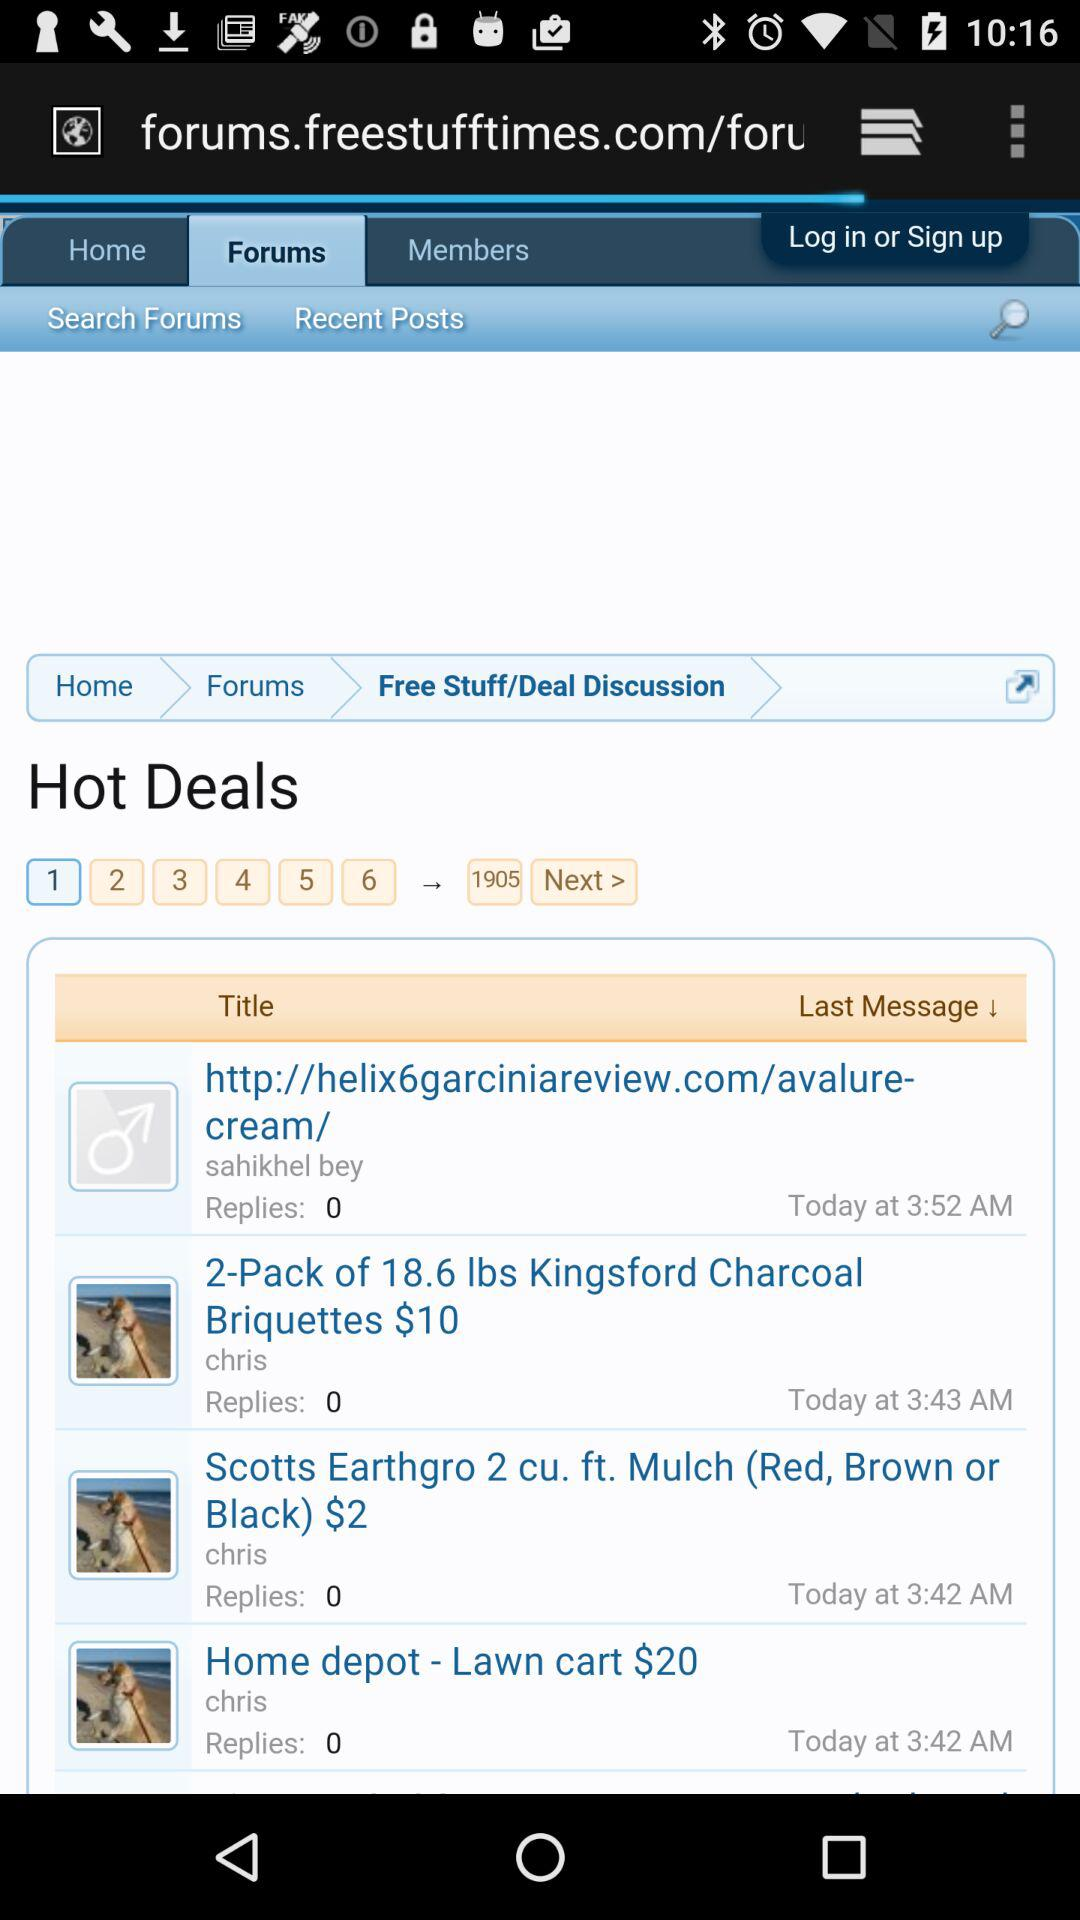How many replies are there for the deal posted by Chris at 3:43 AM? There are 0 replies for the deal posted by Chris at 3:43 AM. 